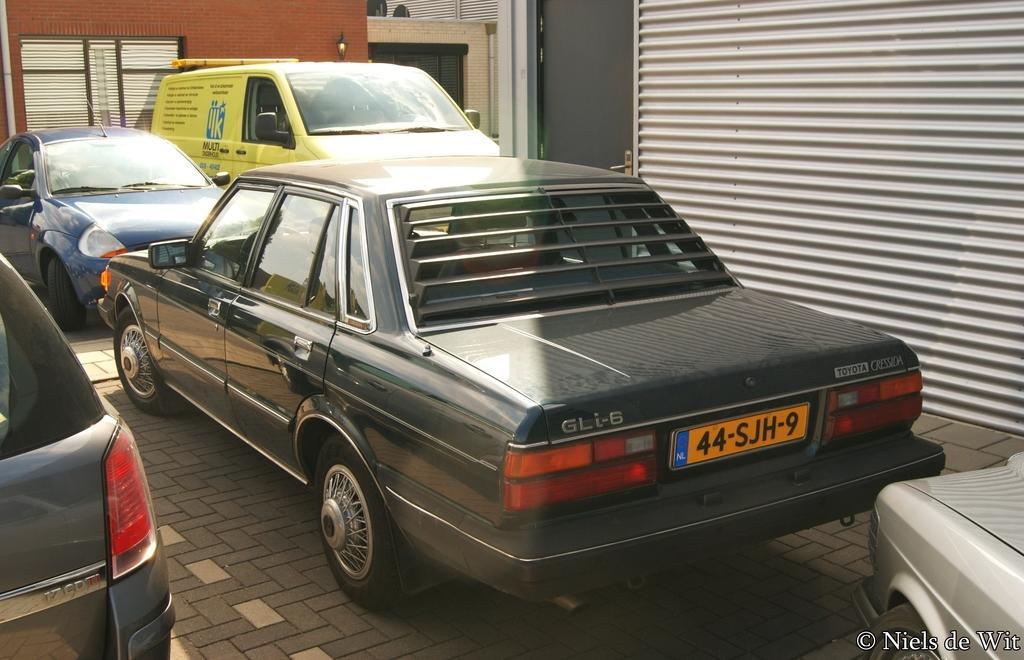Describe this image in one or two sentences. In this picture there are vehicles and buildings. 